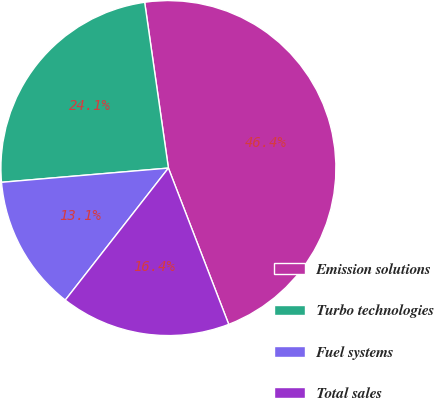Convert chart to OTSL. <chart><loc_0><loc_0><loc_500><loc_500><pie_chart><fcel>Emission solutions<fcel>Turbo technologies<fcel>Fuel systems<fcel>Total sales<nl><fcel>46.4%<fcel>24.09%<fcel>13.09%<fcel>16.42%<nl></chart> 